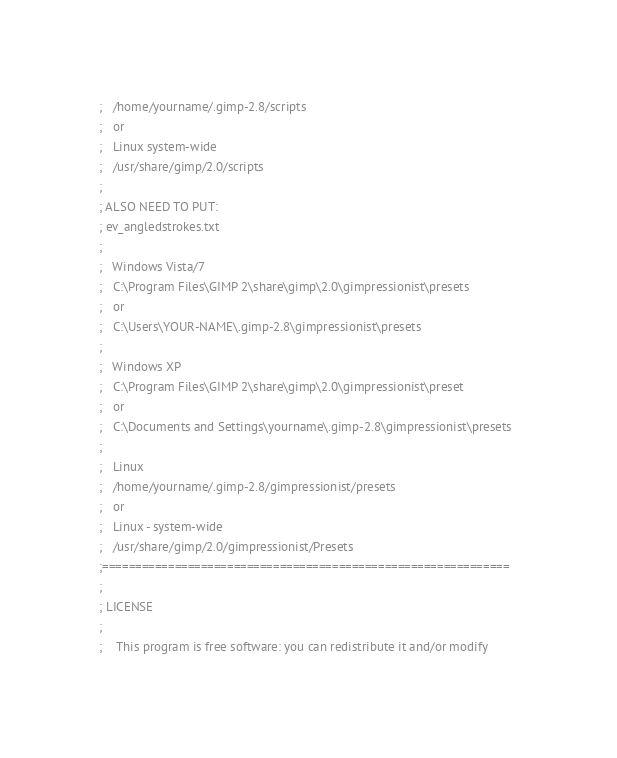<code> <loc_0><loc_0><loc_500><loc_500><_Scheme_>;	/home/yourname/.gimp-2.8/scripts  
;	or
;	Linux system-wide
;	/usr/share/gimp/2.0/scripts
;
; ALSO NEED TO PUT:
; ev_angledstrokes.txt
;
;	Windows Vista/7
;	C:\Program Files\GIMP 2\share\gimp\2.0\gimpressionist\presets
;	or
;	C:\Users\YOUR-NAME\.gimp-2.8\gimpressionist\presets
;	
;	Windows XP
;	C:\Program Files\GIMP 2\share\gimp\2.0\gimpressionist\preset
;	or
;	C:\Documents and Settings\yourname\.gimp-2.8\gimpressionist\presets  
;    
;	Linux
;	/home/yourname/.gimp-2.8/gimpressionist/presets 
;	or
;	Linux - system-wide
;	/usr/share/gimp/2.0/gimpressionist/Presets 
;==============================================================
;
; LICENSE
;
;    This program is free software: you can redistribute it and/or modify</code> 